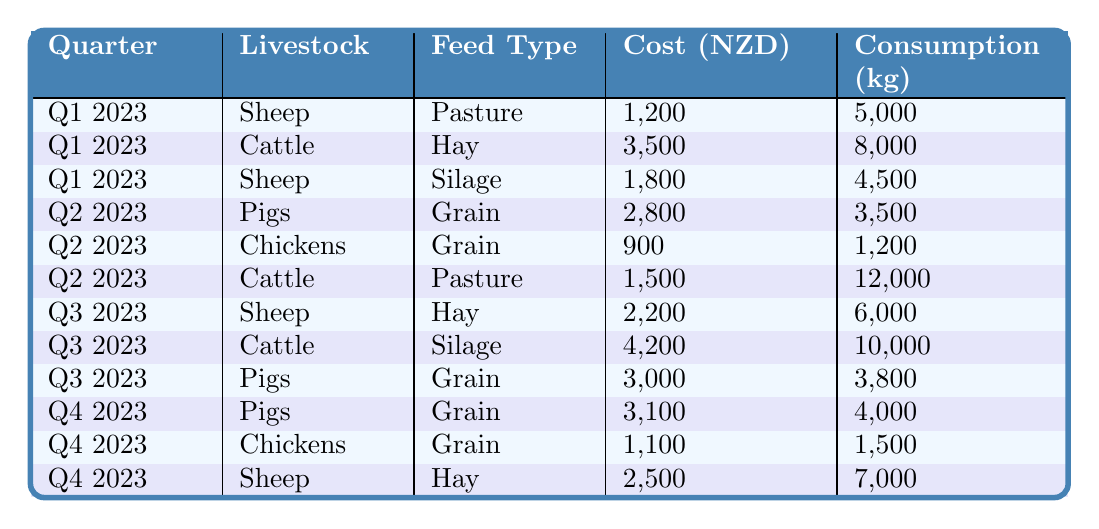What is the total feed cost for sheep in Q1 2023? From the table, the costs for sheep in Q1 2023 are 1,200 NZD (Pasture) and 1,800 NZD (Silage). Adding these together: 1,200 + 1,800 equals 3,000 NZD.
Answer: 3,000 NZD How much feed did pigs consume in Q2 2023? The table shows that pigs consumed 3,500 kg in Q2 2023 for grain feed.
Answer: 3,500 kg Which livestock had the highest consumption of feed in Q3 2023? From the table, cattle consumed 10,000 kg from silage, while sheep consumed 6,000 kg from hay and pigs consumed 3,800 kg from grain. The highest consumption is thus 10,000 kg by cattle.
Answer: Cattle What is the average feed cost for chickens across all quarters? The feed costs for chickens are 900 NZD (Q2), 1,100 NZD (Q4). Adding these gives 900 + 1,100 = 2,000 NZD. There are two data points, so the average is 2,000 / 2 = 1,000 NZD.
Answer: 1,000 NZD Did the cost of feed for cattle increase from Q1 2023 to Q3 2023? In Q1 2023, cattle's feed cost is 3,500 NZD, and in Q3 2023, it is 4,200 NZD. Since 4,200 is greater than 3,500, the cost has increased.
Answer: Yes What is the total feed consumption for sheep in Q4 2023? The table states that sheep consumed 7,000 kg from hay in Q4 2023. This is the only value for sheep in that quarter, so total consumption is 7,000 kg.
Answer: 7,000 kg Which feed type was used for pigs in all quarters? In the table, pigs were only fed grain in Q2 and Q4 2023. Therefore, grain is not used in all quarters, and there is no single feed type that applies to all periods.
Answer: No How much more did cattle cost in Q3 2023 compared to Q2 2023? The cost for cattle in Q3 2023 is 4,200 NZD, and in Q2 2023, it is 1,500 NZD. The difference is 4,200 - 1,500 = 2,700 NZD.
Answer: 2,700 NZD What is the total cost of feed for pigs across all quarters? The costs for pigs are: 2,800 NZD (Q2), 3,000 NZD (Q3), 3,100 NZD (Q4). Adding these gives 2,800 + 3,000 + 3,100 = 8,900 NZD.
Answer: 8,900 NZD How does the consumption of feed for chickens compare between Q2 and Q4 2023? In Q2 2023, chickens consumed 1,200 kg, while in Q4 2023, they consumed 1,500 kg. Since 1,500 kg is greater than 1,200 kg, chickens consumed more in Q4 than in Q2.
Answer: More in Q4 Is the cost of grain for pigs consistent across quarters? The table shows that the cost of grain for pigs is different in different quarters: 2,800 NZD (Q2), 3,000 NZD (Q3), and 3,100 NZD (Q4). This variability indicates inconsistency.
Answer: No 